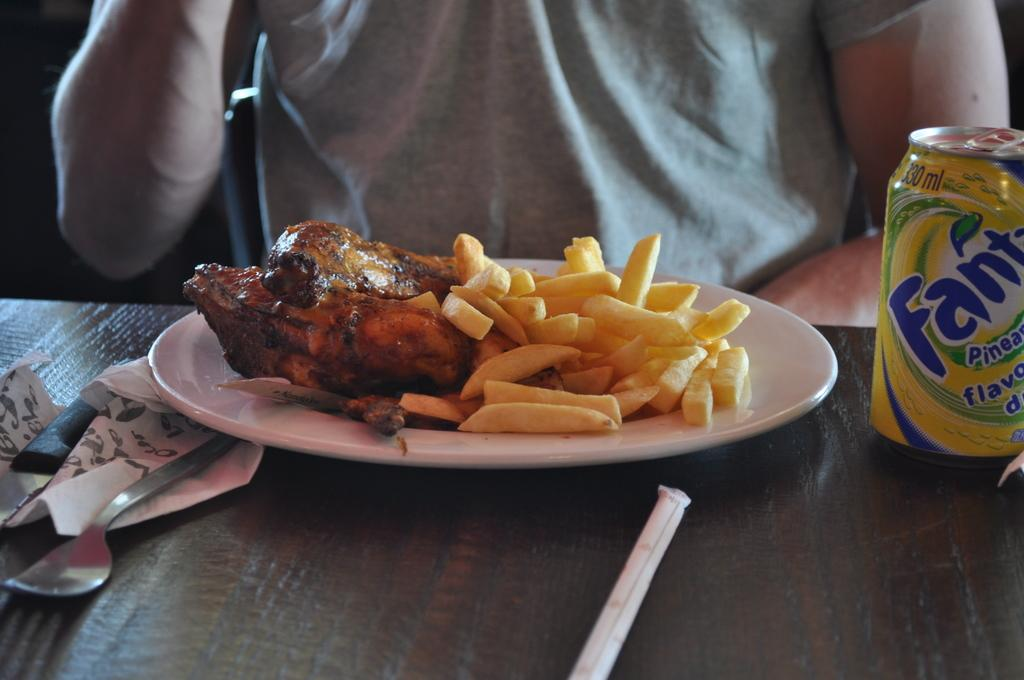What is on the plate in the image? There are food items on a plate in the image. What utensils are visible in the image? There is a spoon and a knife in the image. What type of container is present in the image? There is a tin in the image. What else can be seen on the table in the image? There are other objects on the table in the image. Can you describe the person in the background of the image? There is a person in the background of the image, but no specific details are provided. What channel is the person in the background watching on the television? There is no television present in the image, so it is not possible to determine what channel the person might be watching. 